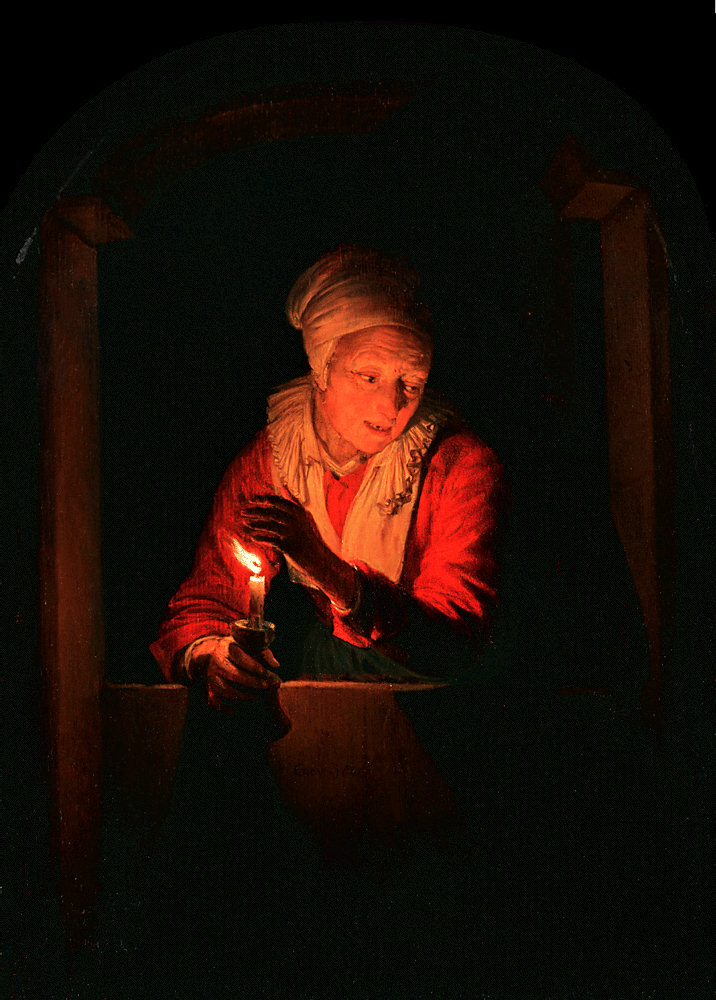This painting exudes a certain warmth. Can you describe the atmosphere and what emotions it might evoke in a viewer? Indeed, the painting radiates warmth and a sense of tranquility. The gentle light from the candle creates a cozy and intimate atmosphere, making the viewer feel as though they are sharing a quiet, personal moment with the elderly woman. The contrast between the warm light and the surrounding darkness amplifies this sense of intimacy, providing comfort and a touch of serenity. In terms of emotions, a viewer might feel nostalgic, reflective, or even a sense of solace, as if the light symbolizes hope and resilience in the face of darkness. 